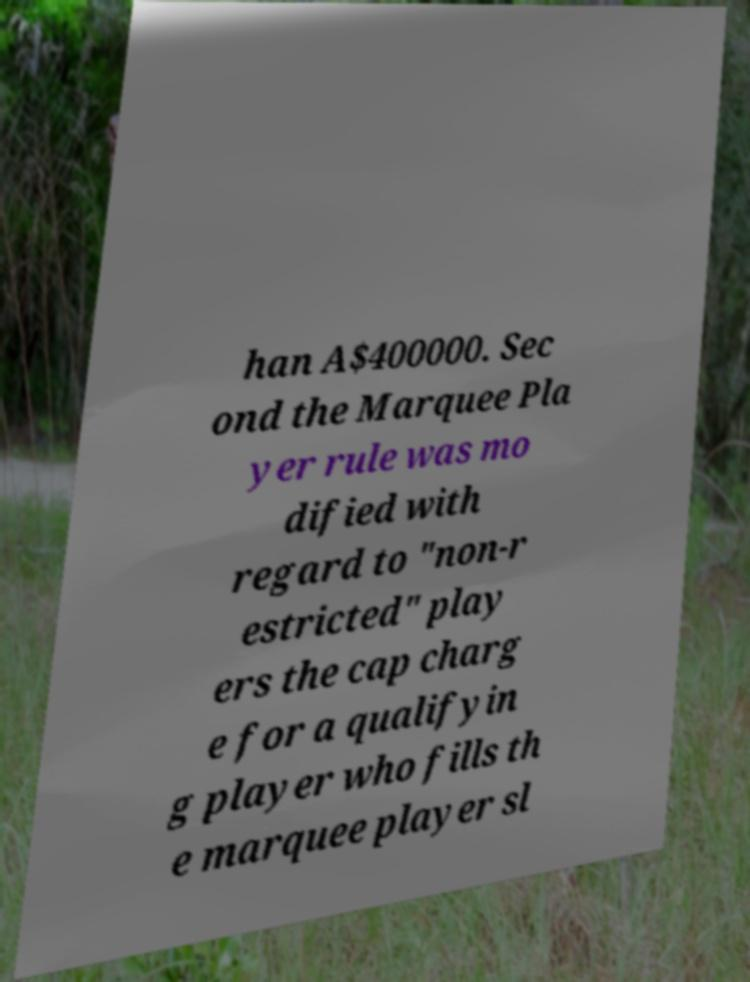I need the written content from this picture converted into text. Can you do that? han A$400000. Sec ond the Marquee Pla yer rule was mo dified with regard to "non-r estricted" play ers the cap charg e for a qualifyin g player who fills th e marquee player sl 